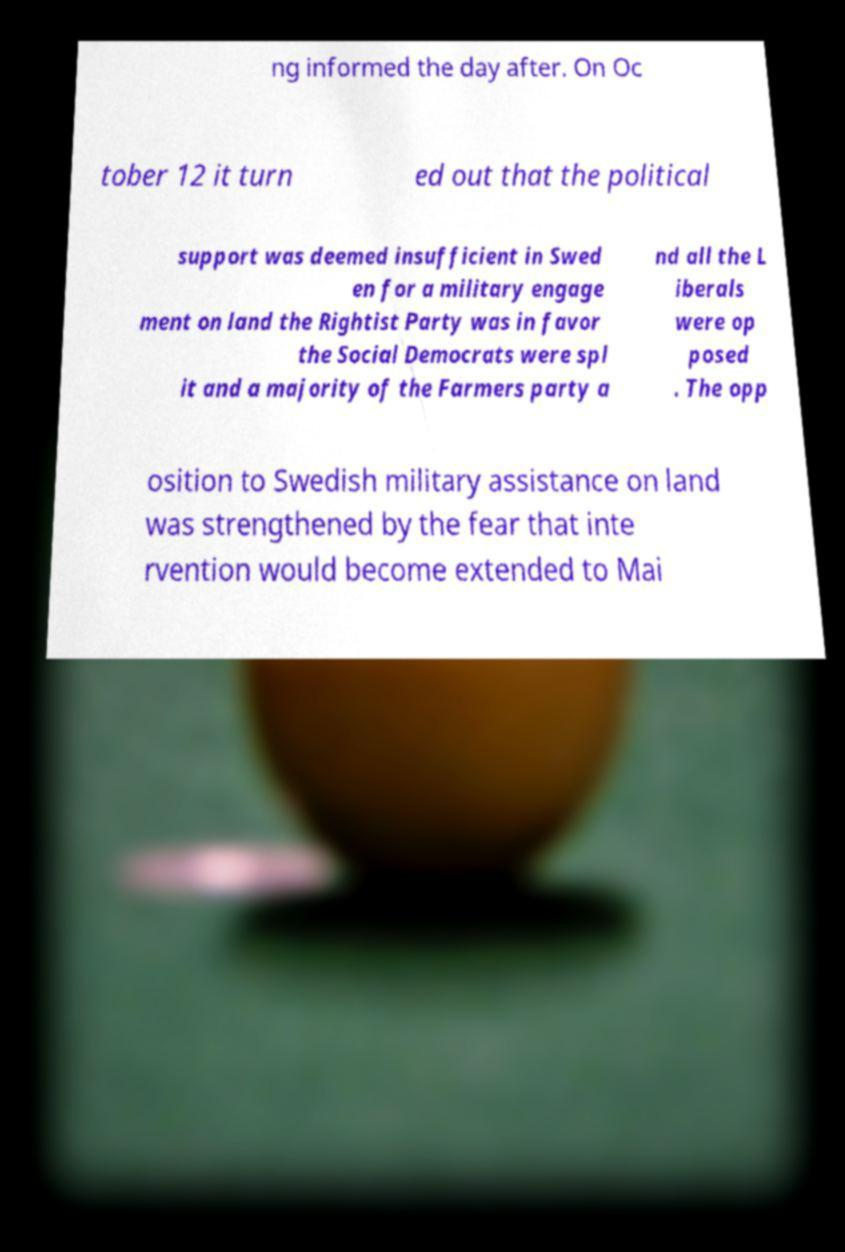Could you assist in decoding the text presented in this image and type it out clearly? ng informed the day after. On Oc tober 12 it turn ed out that the political support was deemed insufficient in Swed en for a military engage ment on land the Rightist Party was in favor the Social Democrats were spl it and a majority of the Farmers party a nd all the L iberals were op posed . The opp osition to Swedish military assistance on land was strengthened by the fear that inte rvention would become extended to Mai 